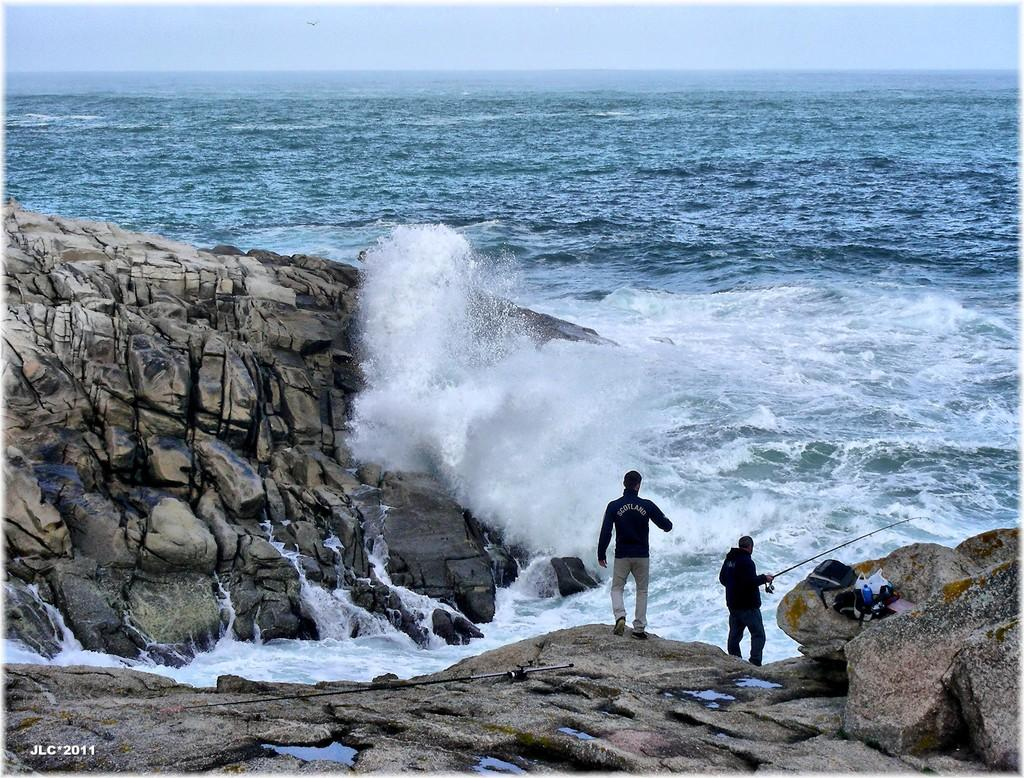How many men are in the image? There are two men in the image. What is one of the men holding in his hand? One of the men is holding a stick in his hand. What type of objects can be seen in the image besides the men? There are rocks, bags, bottles, and water visible in the image. What is visible in the background of the image? The sky is visible in the background of the image. What type of scale can be seen in the image? There is no scale present in the image. How many cubs are visible in the image? There are no cubs present in the image. 